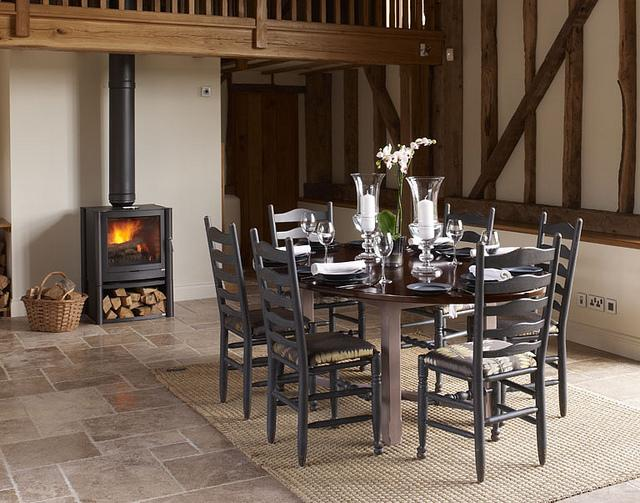What plants help heat this space? Please explain your reasoning. trees. There are logs to heat up the stove. 